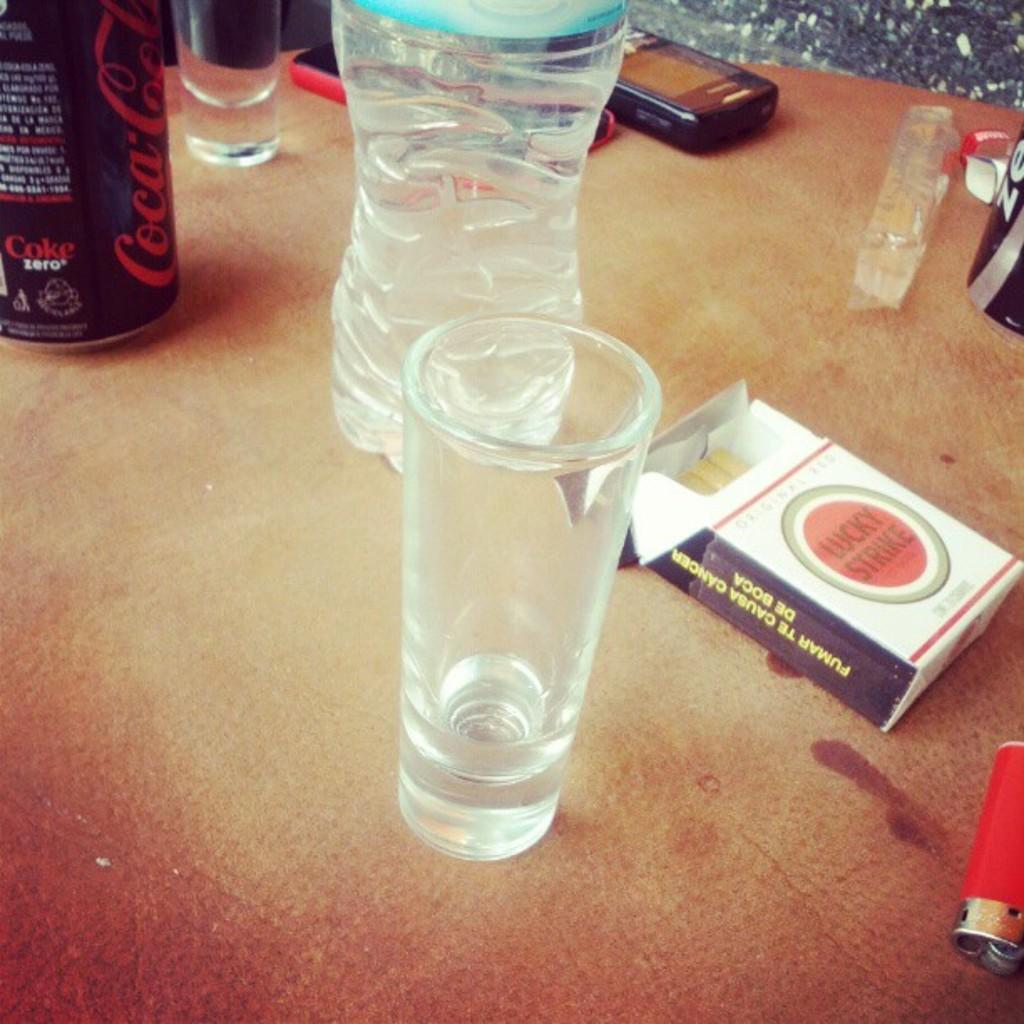What brand of cigarettes are on the table?
Ensure brevity in your answer.  Lucky strike. What type of soda is on the table?
Your response must be concise. Coca-cola. 